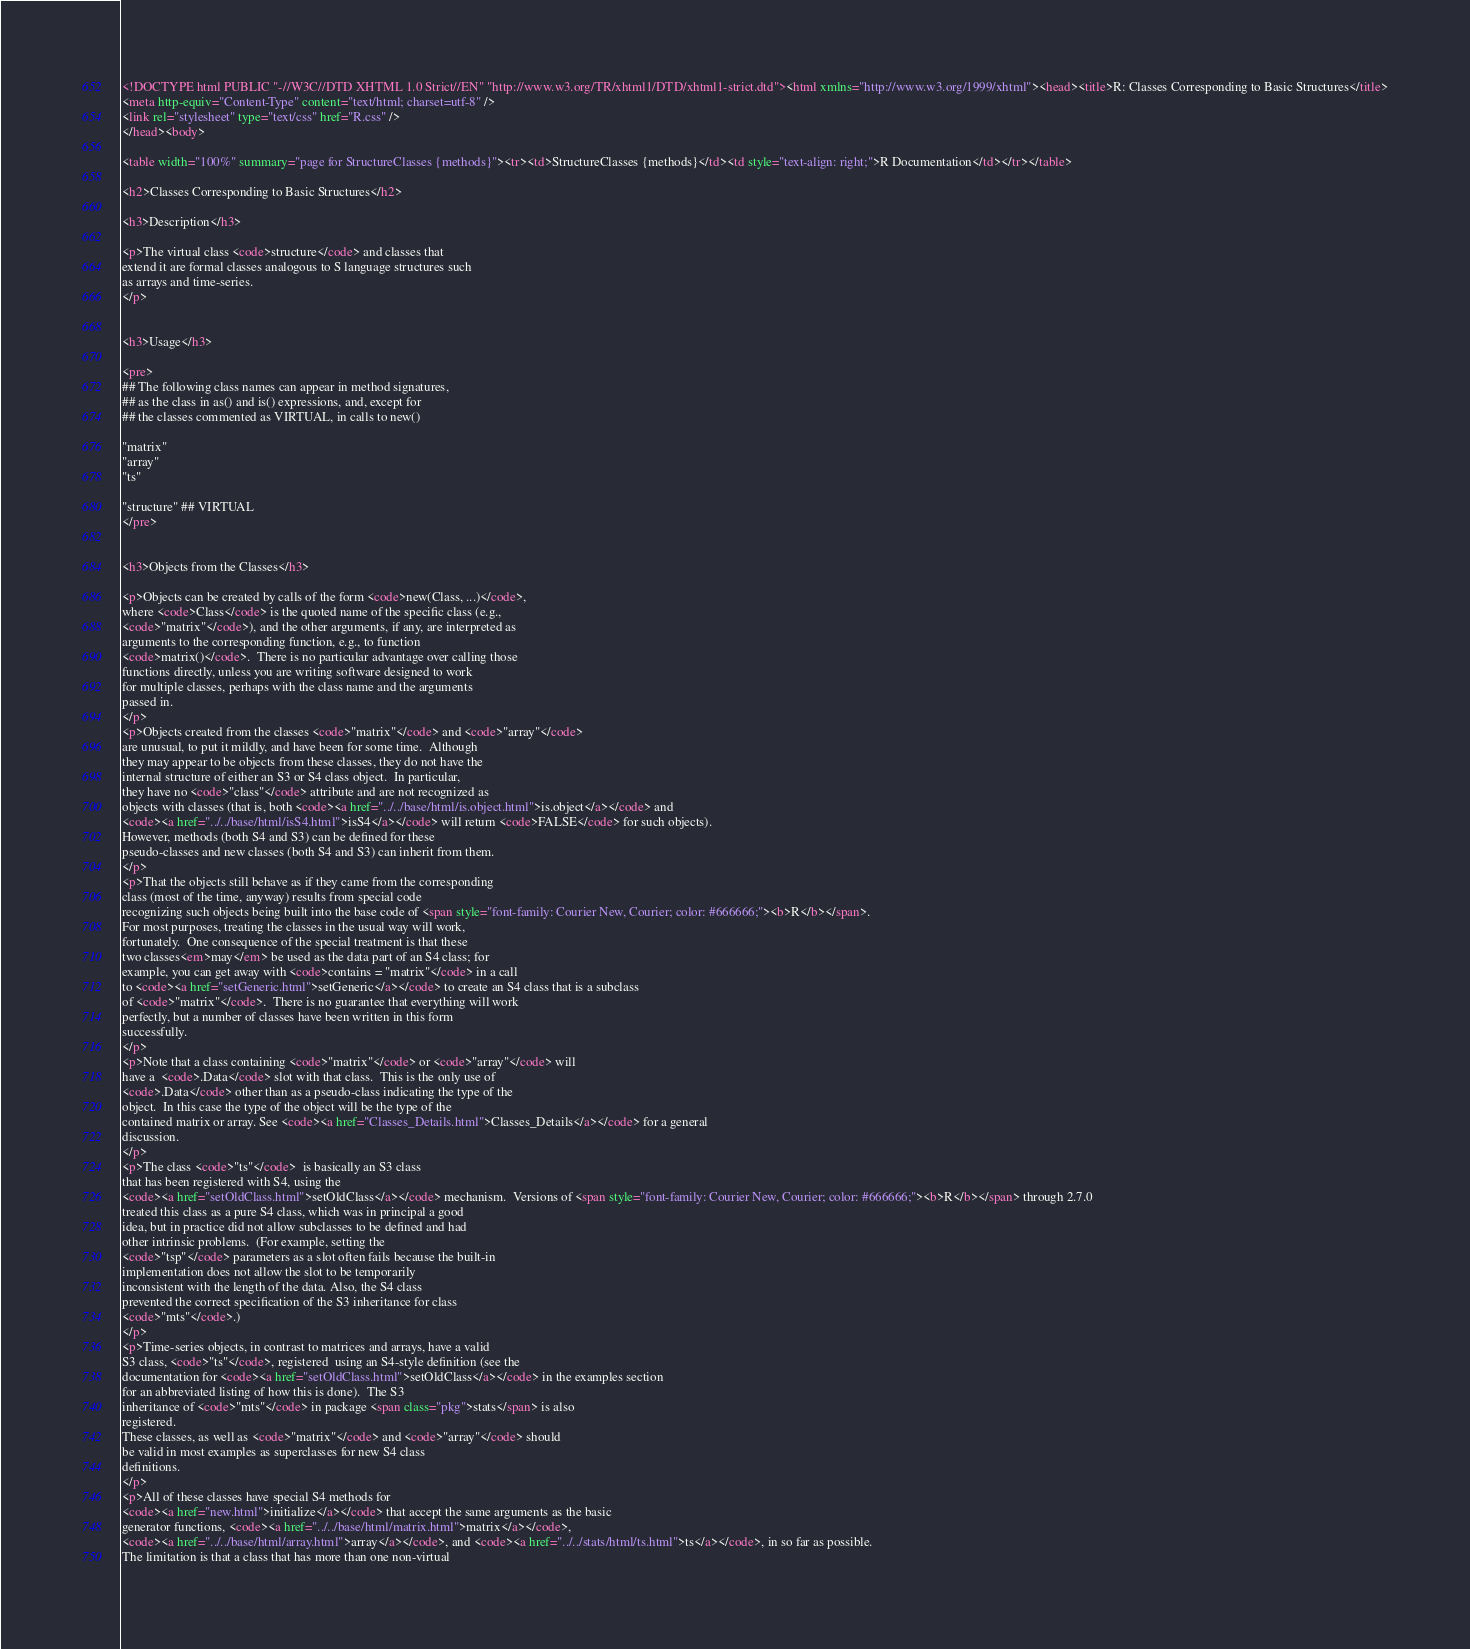<code> <loc_0><loc_0><loc_500><loc_500><_HTML_><!DOCTYPE html PUBLIC "-//W3C//DTD XHTML 1.0 Strict//EN" "http://www.w3.org/TR/xhtml1/DTD/xhtml1-strict.dtd"><html xmlns="http://www.w3.org/1999/xhtml"><head><title>R: Classes Corresponding to Basic Structures</title>
<meta http-equiv="Content-Type" content="text/html; charset=utf-8" />
<link rel="stylesheet" type="text/css" href="R.css" />
</head><body>

<table width="100%" summary="page for StructureClasses {methods}"><tr><td>StructureClasses {methods}</td><td style="text-align: right;">R Documentation</td></tr></table>

<h2>Classes Corresponding to Basic Structures</h2>

<h3>Description</h3>

<p>The virtual class <code>structure</code> and classes that
extend it are formal classes analogous to S language structures such
as arrays and time-series.
</p>


<h3>Usage</h3>

<pre>
## The following class names can appear in method signatures,
## as the class in as() and is() expressions, and, except for
## the classes commented as VIRTUAL, in calls to new()

"matrix"
"array"
"ts"

"structure" ## VIRTUAL
</pre>


<h3>Objects from the Classes</h3>

<p>Objects can be created by calls of the form <code>new(Class, ...)</code>,
where <code>Class</code> is the quoted name of the specific class (e.g.,
<code>"matrix"</code>), and the other arguments, if any, are interpreted as
arguments to the corresponding function, e.g., to function
<code>matrix()</code>.  There is no particular advantage over calling those
functions directly, unless you are writing software designed to work
for multiple classes, perhaps with the class name and the arguments
passed in.
</p>
<p>Objects created from the classes <code>"matrix"</code> and <code>"array"</code>
are unusual, to put it mildly, and have been for some time.  Although
they may appear to be objects from these classes, they do not have the
internal structure of either an S3 or S4 class object.  In particular,
they have no <code>"class"</code> attribute and are not recognized as
objects with classes (that is, both <code><a href="../../base/html/is.object.html">is.object</a></code> and
<code><a href="../../base/html/isS4.html">isS4</a></code> will return <code>FALSE</code> for such objects).
However, methods (both S4 and S3) can be defined for these
pseudo-classes and new classes (both S4 and S3) can inherit from them.
</p>
<p>That the objects still behave as if they came from the corresponding
class (most of the time, anyway) results from special code
recognizing such objects being built into the base code of <span style="font-family: Courier New, Courier; color: #666666;"><b>R</b></span>.
For most purposes, treating the classes in the usual way will work,
fortunately.  One consequence of the special treatment is that these
two classes<em>may</em> be used as the data part of an S4 class; for
example, you can get away with <code>contains = "matrix"</code> in a call
to <code><a href="setGeneric.html">setGeneric</a></code> to create an S4 class that is a subclass
of <code>"matrix"</code>.  There is no guarantee that everything will work
perfectly, but a number of classes have been written in this form
successfully.
</p>
<p>Note that a class containing <code>"matrix"</code> or <code>"array"</code> will
have a  <code>.Data</code> slot with that class.  This is the only use of
<code>.Data</code> other than as a pseudo-class indicating the type of the
object.  In this case the type of the object will be the type of the
contained matrix or array. See <code><a href="Classes_Details.html">Classes_Details</a></code> for a general
discussion.
</p>
<p>The class <code>"ts"</code>  is basically an S3 class
that has been registered with S4, using the
<code><a href="setOldClass.html">setOldClass</a></code> mechanism.  Versions of <span style="font-family: Courier New, Courier; color: #666666;"><b>R</b></span> through 2.7.0
treated this class as a pure S4 class, which was in principal a good
idea, but in practice did not allow subclasses to be defined and had
other intrinsic problems.  (For example, setting the
<code>"tsp"</code> parameters as a slot often fails because the built-in
implementation does not allow the slot to be temporarily
inconsistent with the length of the data. Also, the S4 class
prevented the correct specification of the S3 inheritance for class
<code>"mts"</code>.)
</p>
<p>Time-series objects, in contrast to matrices and arrays, have a valid
S3 class, <code>"ts"</code>, registered  using an S4-style definition (see the
documentation for <code><a href="setOldClass.html">setOldClass</a></code> in the examples section
for an abbreviated listing of how this is done).  The S3
inheritance of <code>"mts"</code> in package <span class="pkg">stats</span> is also
registered.
These classes, as well as <code>"matrix"</code> and <code>"array"</code> should
be valid in most examples as superclasses for new S4 class
definitions.
</p>
<p>All of these classes have special S4 methods for
<code><a href="new.html">initialize</a></code> that accept the same arguments as the basic
generator functions, <code><a href="../../base/html/matrix.html">matrix</a></code>,
<code><a href="../../base/html/array.html">array</a></code>, and <code><a href="../../stats/html/ts.html">ts</a></code>, in so far as possible.
The limitation is that a class that has more than one non-virtual</code> 